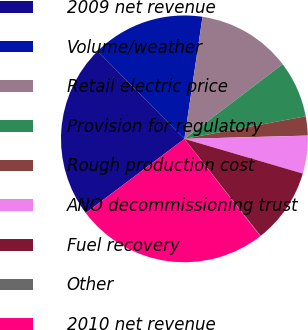<chart> <loc_0><loc_0><loc_500><loc_500><pie_chart><fcel>2009 net revenue<fcel>Volume/weather<fcel>Retail electric price<fcel>Provision for regulatory<fcel>Rough production cost<fcel>ANO decommissioning trust<fcel>Fuel recovery<fcel>Other<fcel>2010 net revenue<nl><fcel>22.83%<fcel>14.77%<fcel>12.31%<fcel>7.41%<fcel>2.51%<fcel>4.96%<fcel>9.86%<fcel>0.06%<fcel>25.28%<nl></chart> 